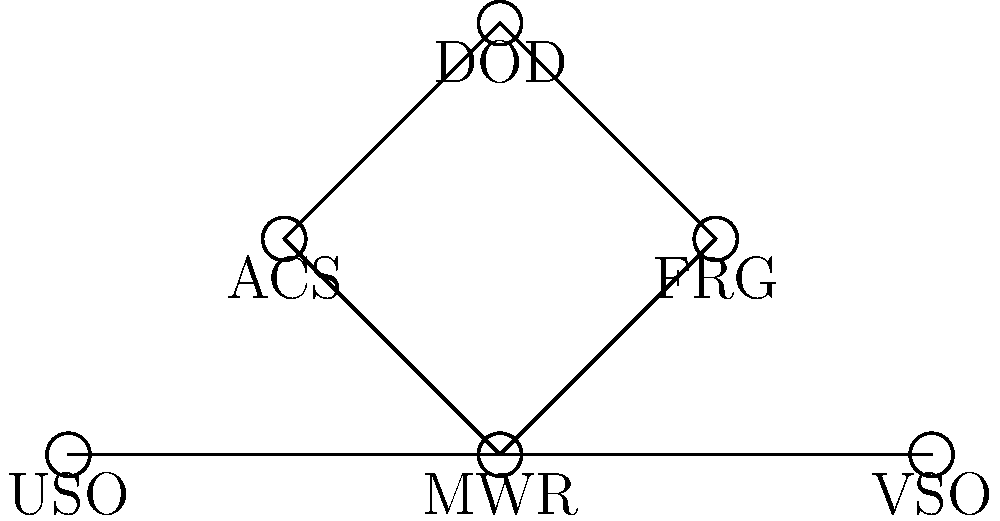In the network diagram of military family support organizations, which organization serves as the central node, connecting to the most other organizations? To determine the central node in this network diagram, we need to follow these steps:

1. Identify all the organizations represented in the diagram:
   - MWR (Morale, Welfare, and Recreation)
   - FRG (Family Readiness Group)
   - ACS (Army Community Service)
   - DOD (Department of Defense)
   - VSO (Veteran Service Organization)
   - USO (United Service Organizations)

2. Count the number of connections (edges) for each organization:
   - MWR: 4 connections (to FRG, ACS, VSO, and USO)
   - FRG: 2 connections (to MWR and DOD)
   - ACS: 2 connections (to MWR and DOD)
   - DOD: 2 connections (to FRG and ACS)
   - VSO: 2 connections (to MWR and USO)
   - USO: 2 connections (to MWR and VSO)

3. Identify the organization with the most connections:
   MWR has the highest number of connections with 4, making it the central node in this network.

4. Understand the significance:
   As the central node, MWR plays a crucial role in coordinating and connecting various support organizations for military families. This position allows MWR to facilitate communication and collaboration between different entities, ensuring a more comprehensive support network for service members and their families.
Answer: MWR (Morale, Welfare, and Recreation) 